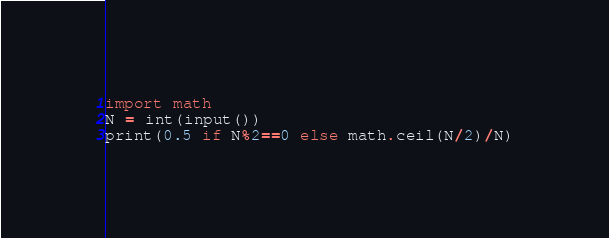<code> <loc_0><loc_0><loc_500><loc_500><_Python_>import math
N = int(input())
print(0.5 if N%2==0 else math.ceil(N/2)/N)</code> 